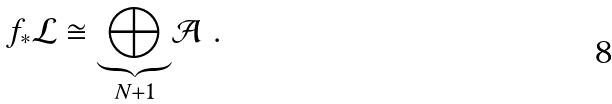Convert formula to latex. <formula><loc_0><loc_0><loc_500><loc_500>f _ { * } \mathcal { L } \cong \underset { N + 1 } { \underbrace { \bigoplus } } \mathcal { A } \ .</formula> 